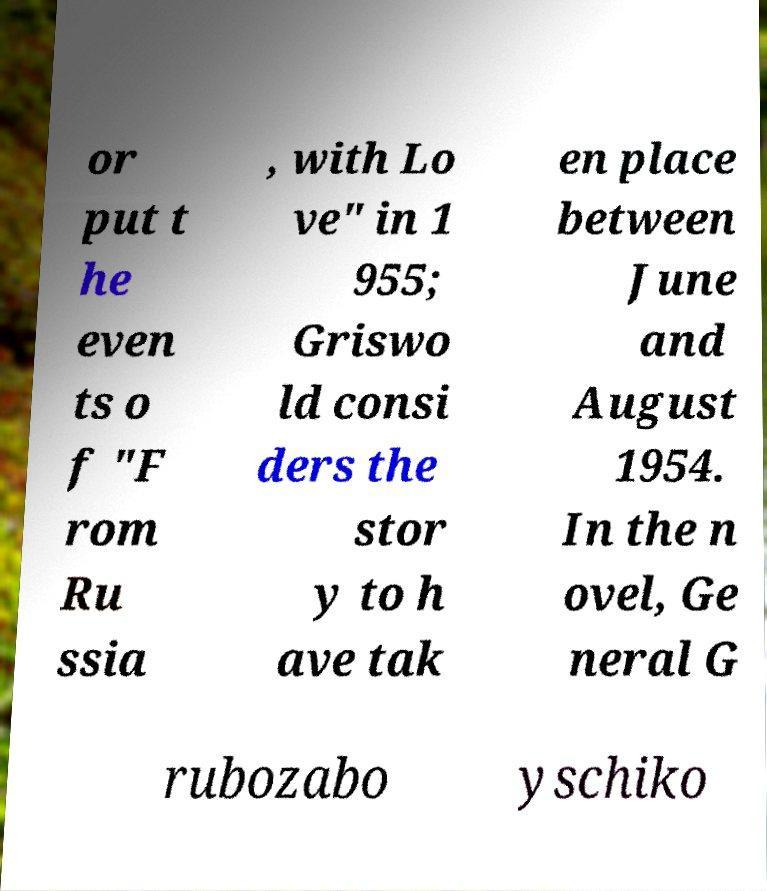I need the written content from this picture converted into text. Can you do that? or put t he even ts o f "F rom Ru ssia , with Lo ve" in 1 955; Griswo ld consi ders the stor y to h ave tak en place between June and August 1954. In the n ovel, Ge neral G rubozabo yschiko 